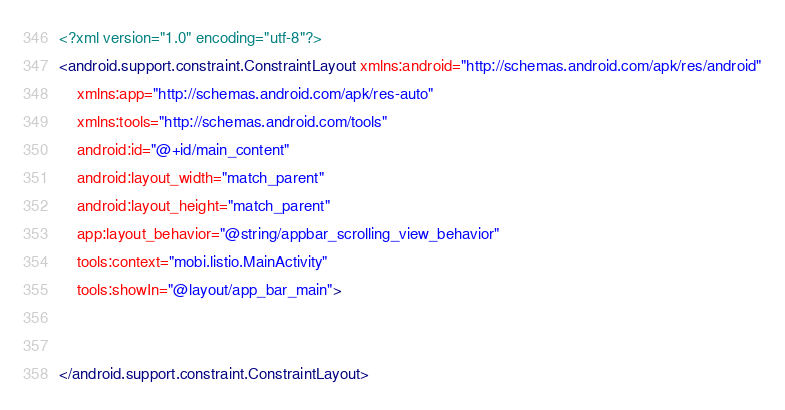<code> <loc_0><loc_0><loc_500><loc_500><_XML_><?xml version="1.0" encoding="utf-8"?>
<android.support.constraint.ConstraintLayout xmlns:android="http://schemas.android.com/apk/res/android"
    xmlns:app="http://schemas.android.com/apk/res-auto"
    xmlns:tools="http://schemas.android.com/tools"
    android:id="@+id/main_content"
    android:layout_width="match_parent"
    android:layout_height="match_parent"
    app:layout_behavior="@string/appbar_scrolling_view_behavior"
    tools:context="mobi.listio.MainActivity"
    tools:showIn="@layout/app_bar_main">


</android.support.constraint.ConstraintLayout>
</code> 